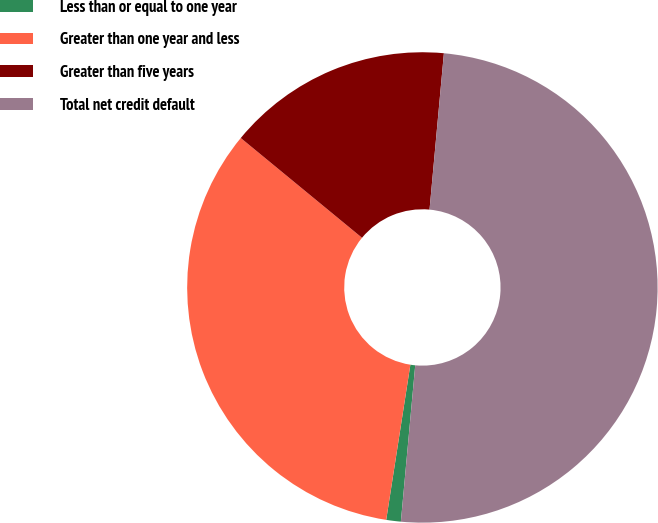<chart> <loc_0><loc_0><loc_500><loc_500><pie_chart><fcel>Less than or equal to one year<fcel>Greater than one year and less<fcel>Greater than five years<fcel>Total net credit default<nl><fcel>1.0%<fcel>33.5%<fcel>15.5%<fcel>50.0%<nl></chart> 